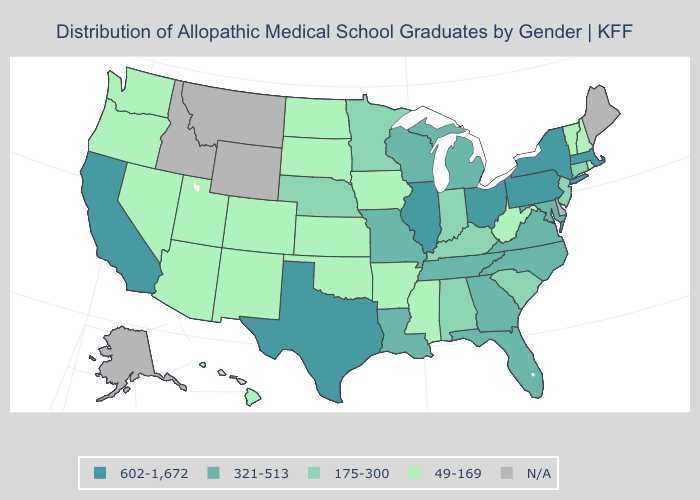Does the map have missing data?
Answer briefly. Yes. Does the first symbol in the legend represent the smallest category?
Be succinct. No. Does the map have missing data?
Answer briefly. Yes. Which states have the lowest value in the USA?
Give a very brief answer. Arizona, Arkansas, Colorado, Hawaii, Iowa, Kansas, Mississippi, Nevada, New Hampshire, New Mexico, North Dakota, Oklahoma, Oregon, Rhode Island, South Dakota, Utah, Vermont, Washington, West Virginia. What is the lowest value in the MidWest?
Keep it brief. 49-169. Which states have the highest value in the USA?
Be succinct. California, Illinois, Massachusetts, New York, Ohio, Pennsylvania, Texas. Name the states that have a value in the range 602-1,672?
Quick response, please. California, Illinois, Massachusetts, New York, Ohio, Pennsylvania, Texas. What is the value of Colorado?
Answer briefly. 49-169. Among the states that border Kentucky , which have the highest value?
Answer briefly. Illinois, Ohio. Which states have the lowest value in the MidWest?
Answer briefly. Iowa, Kansas, North Dakota, South Dakota. Name the states that have a value in the range 175-300?
Short answer required. Alabama, Connecticut, Indiana, Kentucky, Minnesota, Nebraska, New Jersey, South Carolina. Is the legend a continuous bar?
Give a very brief answer. No. What is the value of Massachusetts?
Be succinct. 602-1,672. What is the value of South Carolina?
Quick response, please. 175-300. 